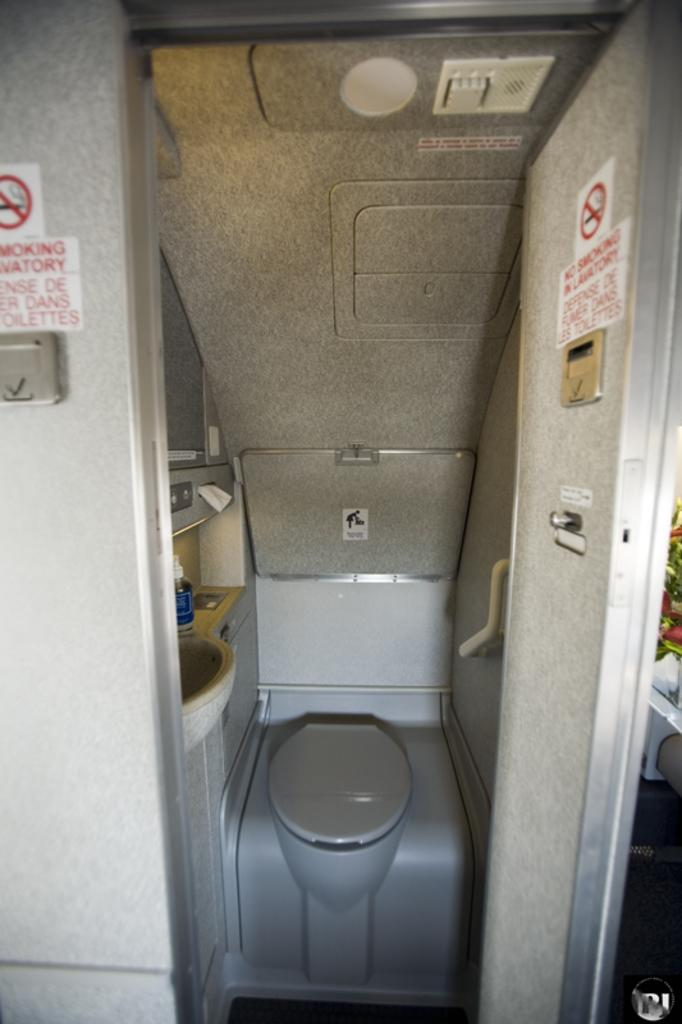Provide a one-sentence caption for the provided image. An airplane bathroom has a No Smoking sign on the door. 